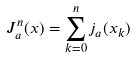<formula> <loc_0><loc_0><loc_500><loc_500>J _ { a } ^ { n } ( x ) = \sum _ { k = 0 } ^ { n } j _ { a } ( x _ { k } )</formula> 